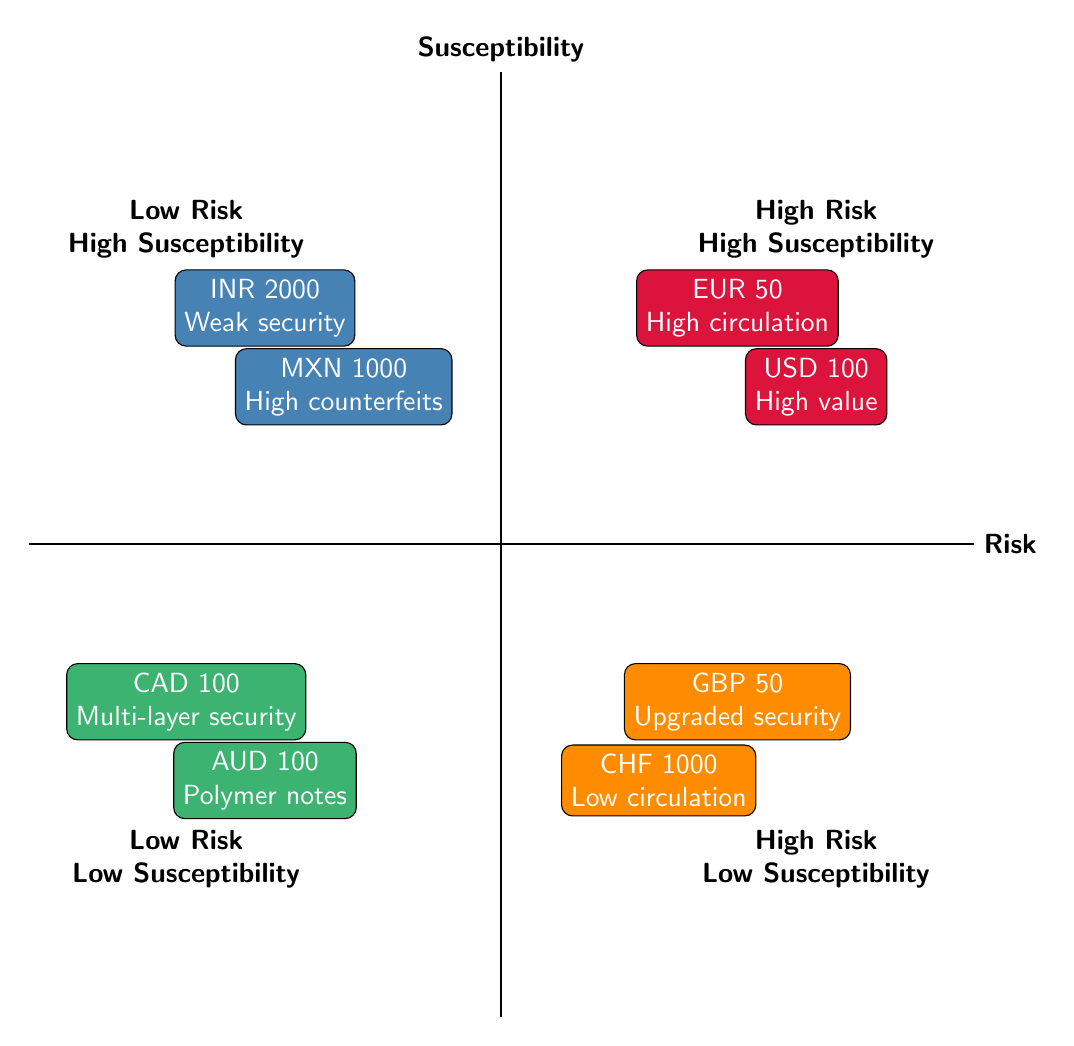What currency has the highest susceptibility in the high-risk category? The high-risk category consists of two currencies: Euro (50 EUR) and US Dollar (100 USD). To determine which has the highest susceptibility, I look for the descriptions in their nodes. Both currencies are marked as high susceptibility, but seeing that the Euro is placed higher reflects its more significant risk due to common circulation issues.
Answer: Euro (EUR) How many currencies are there in the low-risk low-susceptibility quadrant? In the low-risk low-susceptibility quadrant, there are two currencies displayed: Australian Dollar (100 AUD) and Canadian Dollar (100 CAD). Counting these currencies gives a total of two.
Answer: 2 Which currency represents high value in relation to counterfeit susceptibility? Looking through the quadrants, the US Dollar (100 USD) is situated in the high-risk high-susceptibility quadrant. It's noted specifically for its high value and global usage, highlighting its importance regarding susceptibility to counterfeiting.
Answer: US Dollar (USD) What is the notable security feature of the Canadian Dollar? The Canadian Dollar (100 CAD) is identified in the low-risk low-susceptibility quadrant and is characterized by its multiple security layers, which are aimed at reducing counterfeit risks.
Answer: Multi-layer security Which currency is labeled as having weak security? Within the low-risk high-susceptibility quadrant, the Indian Rupee (2000 INR) is marked with a note describing its weak security features. This currency's low sophistication makes it more susceptible to counterfeiting compared to others.
Answer: Indian Rupee (INR) What is the relationship between the British Pound and security upgrades? The British Pound (50 GBP) is positioned in the high-risk low-susceptibility quadrant, where it is mentioned that it has had recent security feature upgrades. This indicates a direct improvement in its reliability against counterfeiting attempts.
Answer: Recent security feature upgrades Which currency has high circulation and high susceptibility? The diagram shows that Euro (50 EUR) is categorized under high risk and high susceptibility, with the note specified as "high circulation," indicating a strong relationship between its widespread use and vulnerability to counterfeiting.
Answer: Euro (EUR) What is the reason for the high counterfeit activity associated with the Mexican Peso? The Mexican Peso (1000 MXN) is categorized in the low-risk high-susceptibility quadrant, noted for its relatively high counterfeit activity. This specific wording highlights its ongoing challenges despite possibly lower risks.
Answer: Relatively high counterfeit activity 